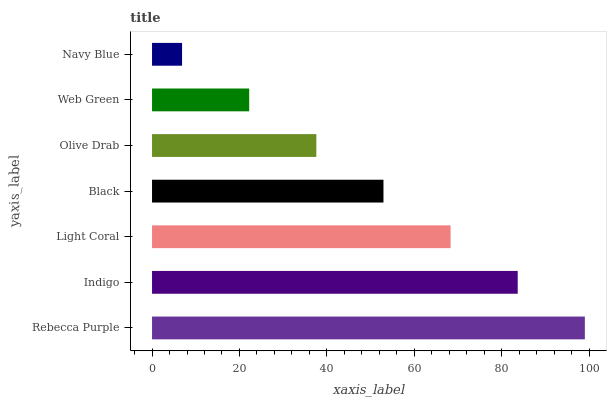Is Navy Blue the minimum?
Answer yes or no. Yes. Is Rebecca Purple the maximum?
Answer yes or no. Yes. Is Indigo the minimum?
Answer yes or no. No. Is Indigo the maximum?
Answer yes or no. No. Is Rebecca Purple greater than Indigo?
Answer yes or no. Yes. Is Indigo less than Rebecca Purple?
Answer yes or no. Yes. Is Indigo greater than Rebecca Purple?
Answer yes or no. No. Is Rebecca Purple less than Indigo?
Answer yes or no. No. Is Black the high median?
Answer yes or no. Yes. Is Black the low median?
Answer yes or no. Yes. Is Web Green the high median?
Answer yes or no. No. Is Indigo the low median?
Answer yes or no. No. 